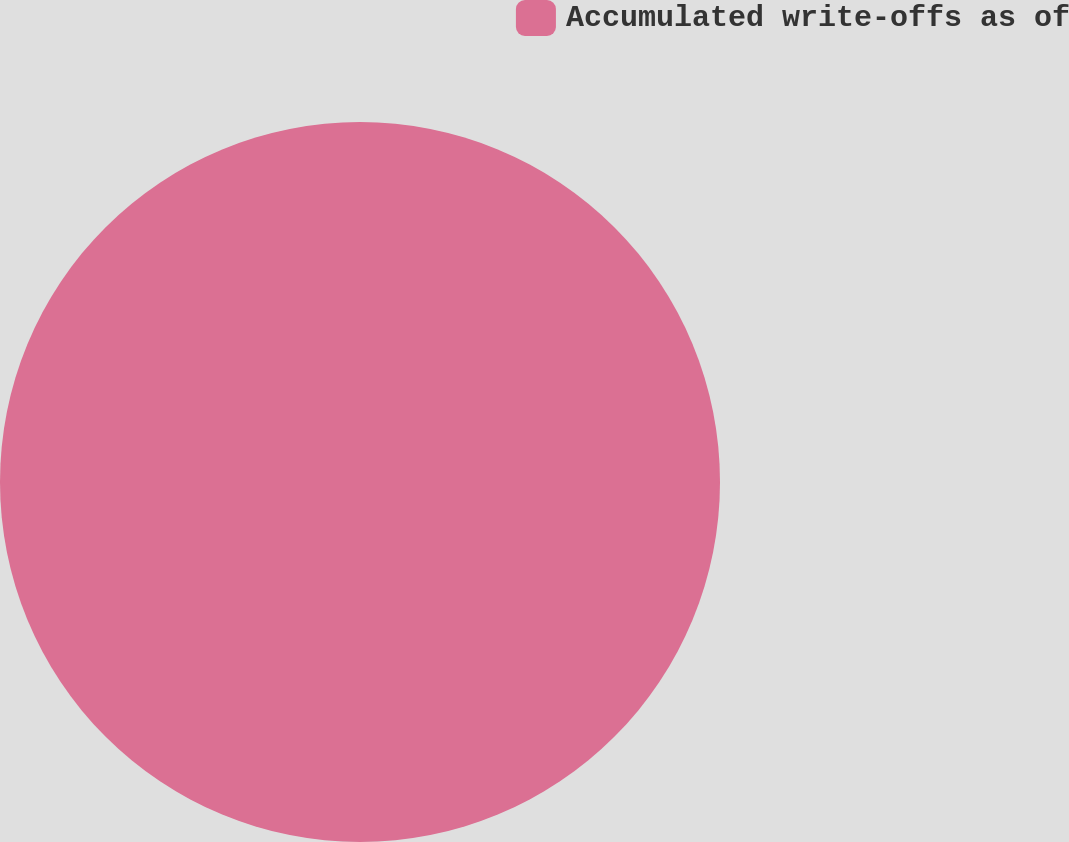<chart> <loc_0><loc_0><loc_500><loc_500><pie_chart><fcel>Accumulated write-offs as of<nl><fcel>100.0%<nl></chart> 